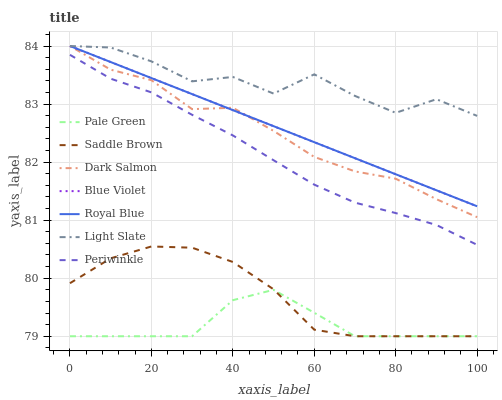Does Pale Green have the minimum area under the curve?
Answer yes or no. Yes. Does Light Slate have the maximum area under the curve?
Answer yes or no. Yes. Does Dark Salmon have the minimum area under the curve?
Answer yes or no. No. Does Dark Salmon have the maximum area under the curve?
Answer yes or no. No. Is Blue Violet the smoothest?
Answer yes or no. Yes. Is Light Slate the roughest?
Answer yes or no. Yes. Is Dark Salmon the smoothest?
Answer yes or no. No. Is Dark Salmon the roughest?
Answer yes or no. No. Does Pale Green have the lowest value?
Answer yes or no. Yes. Does Dark Salmon have the lowest value?
Answer yes or no. No. Does Blue Violet have the highest value?
Answer yes or no. Yes. Does Pale Green have the highest value?
Answer yes or no. No. Is Periwinkle less than Blue Violet?
Answer yes or no. Yes. Is Dark Salmon greater than Saddle Brown?
Answer yes or no. Yes. Does Pale Green intersect Saddle Brown?
Answer yes or no. Yes. Is Pale Green less than Saddle Brown?
Answer yes or no. No. Is Pale Green greater than Saddle Brown?
Answer yes or no. No. Does Periwinkle intersect Blue Violet?
Answer yes or no. No. 